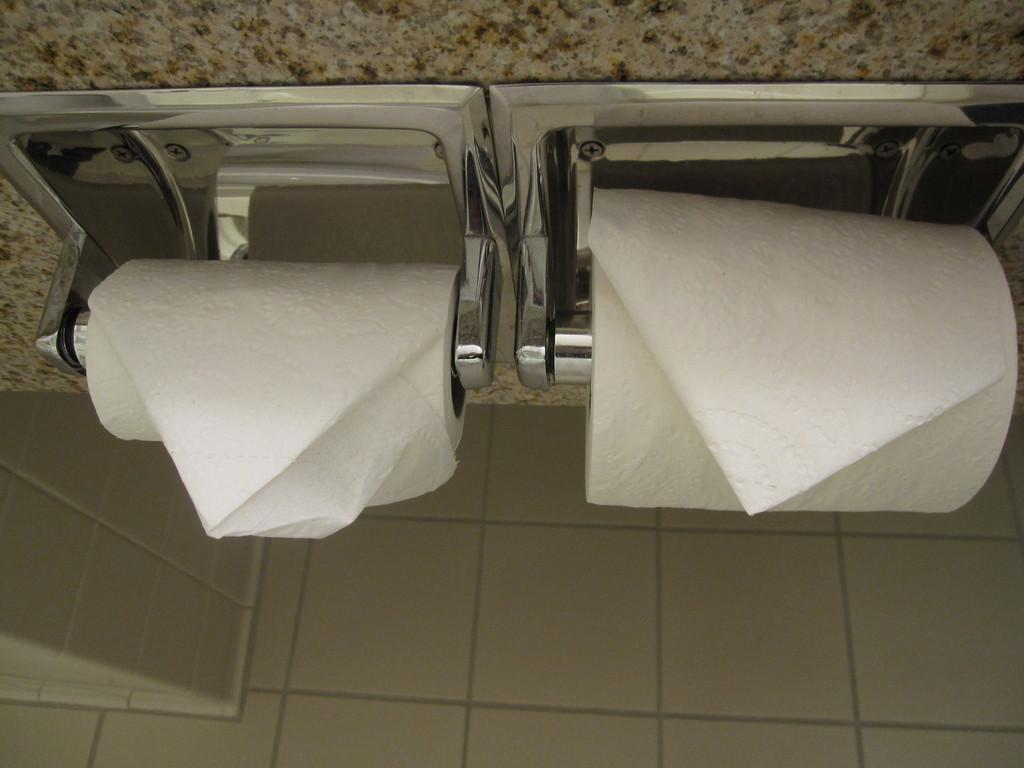What items can be seen in the image related to cleaning or wiping? There are tissues in the image. What objects are present in the image that can hold or store other items? There are holders in the image. What type of structure is visible in the image that separates different areas or spaces? There is a wall in the image. What surface is visible in the image that people walk or stand on? There is a floor in the image. Can you see a branch growing from the wall in the image? There is no branch growing from the wall in the image. Are there any beads hanging from the holders in the image? There is no mention of beads in the image, only holders. 